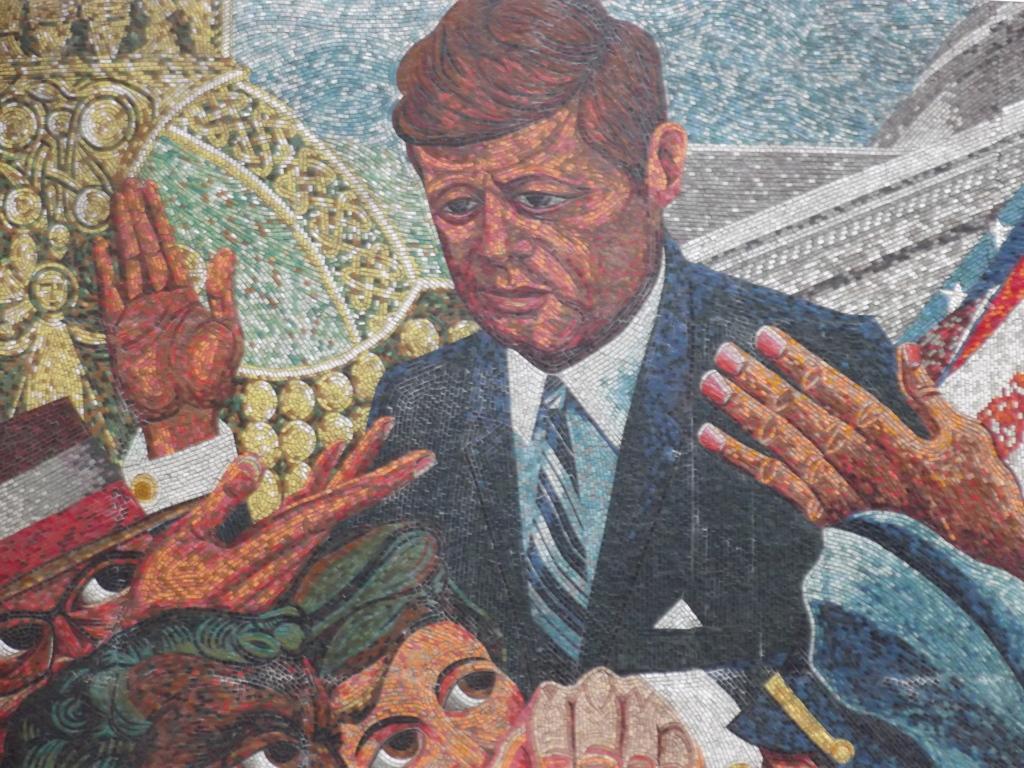Can you describe this image briefly? In this image we can see a beautiful art. 